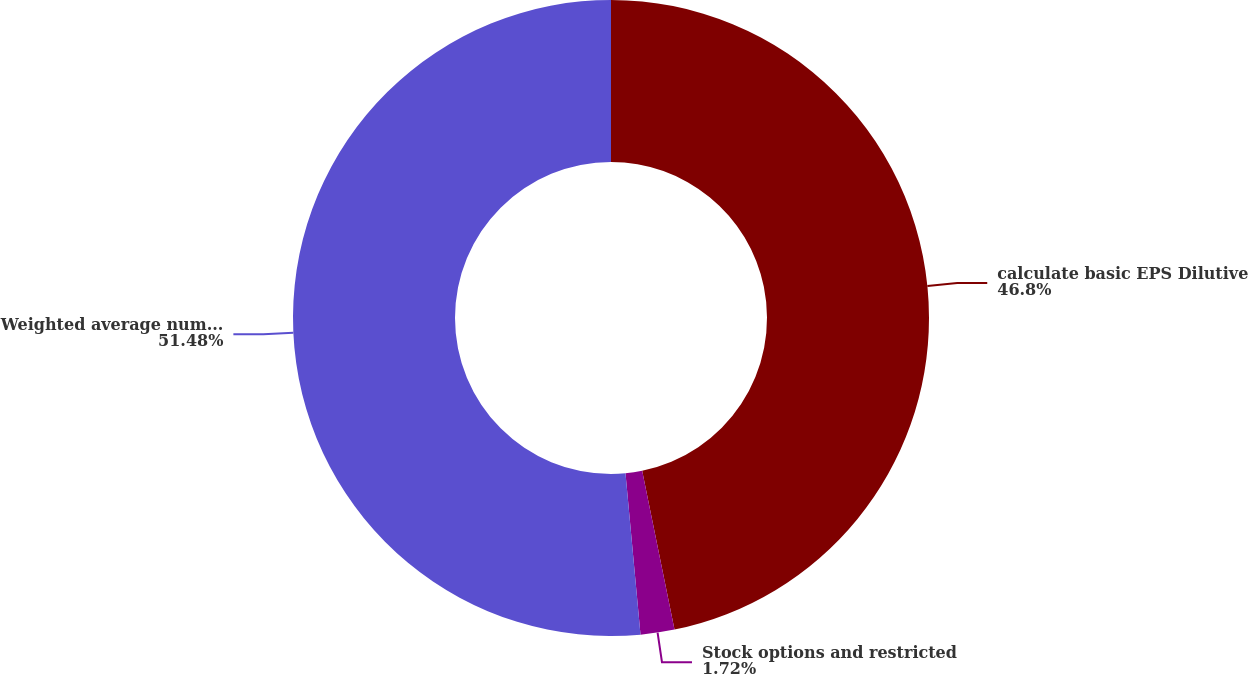<chart> <loc_0><loc_0><loc_500><loc_500><pie_chart><fcel>calculate basic EPS Dilutive<fcel>Stock options and restricted<fcel>Weighted average number of<nl><fcel>46.8%<fcel>1.72%<fcel>51.48%<nl></chart> 